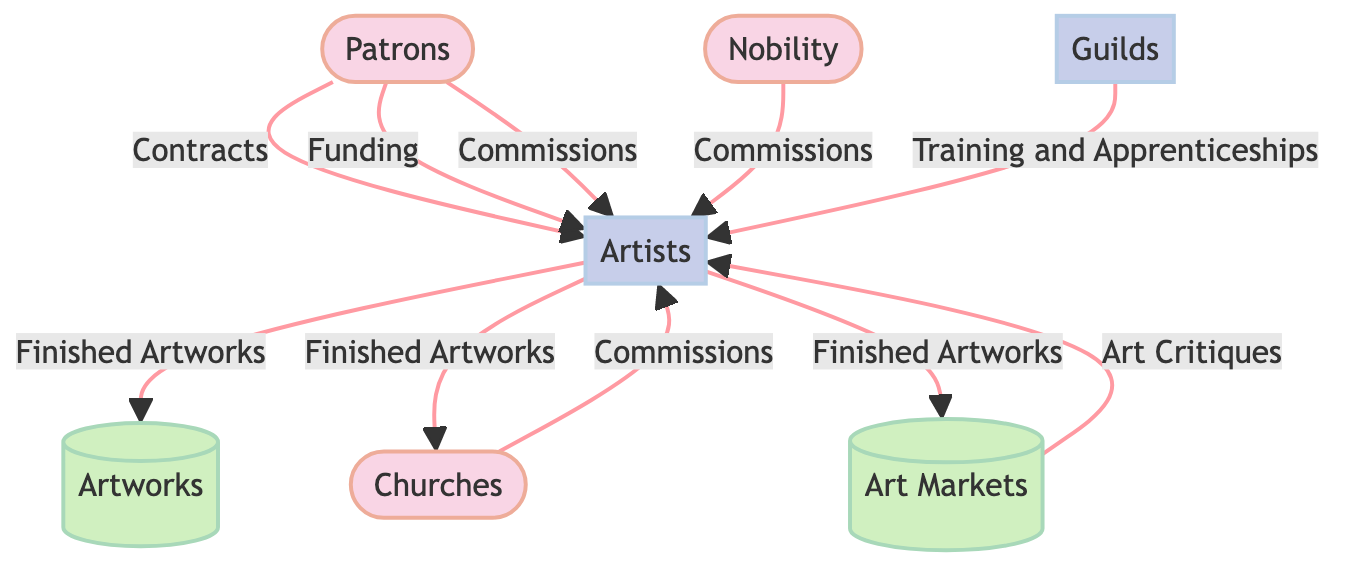What are the three external entities represented in the diagram? By examining the diagram, we can identify the external entities: Patrons, Churches, and Nobility as they are categorized under the 'External Entity' type.
Answer: Patrons, Churches, Nobility How many processes are shown in the diagram? The diagram indicates there are two processes: Artists and Guilds, which are distinguished by 'Process' types.
Answer: 2 What flows are directed from Nobility to Artists? The diagram clearly shows that there are two data flows: Commissions and Funding from Nobility directed towards Artists.
Answer: Commissions, Funding Which entity is responsible for regulating the art trade? The diagram specifies that Guilds are the process responsible for regulating the art trade as indicated in their description.
Answer: Guilds What kind of support do Patrons provide to Artists? Based on the diagram, Patrons provide Funding, Contracts, and Commissions to Artists, which are essential for the production of artworks.
Answer: Funding, Contracts, Commissions What is the purpose of the Art Markets in the diagram? The role of Art Markets, as indicated, is to serve as venues for the sale and distribution of artworks, linking completed pieces to buyers.
Answer: Sale and distribution of artworks What influences artist reputation according to the diagram? The diagram shows that Art Critiques influence artist reputation and market value, serving as feedback for the quality and appeal of their work.
Answer: Art Critiques Which external entity commissions artworks specifically for religious purposes? The diagram indicates that Churches are the external entity commissioning artworks specifically for decor and religious purposes.
Answer: Churches How do Guilds contribute to the development of artists? The diagram illustrates that Guilds provide Training and Apprenticeships, which are crucial for skill development in emerging artists.
Answer: Training and Apprenticeships 